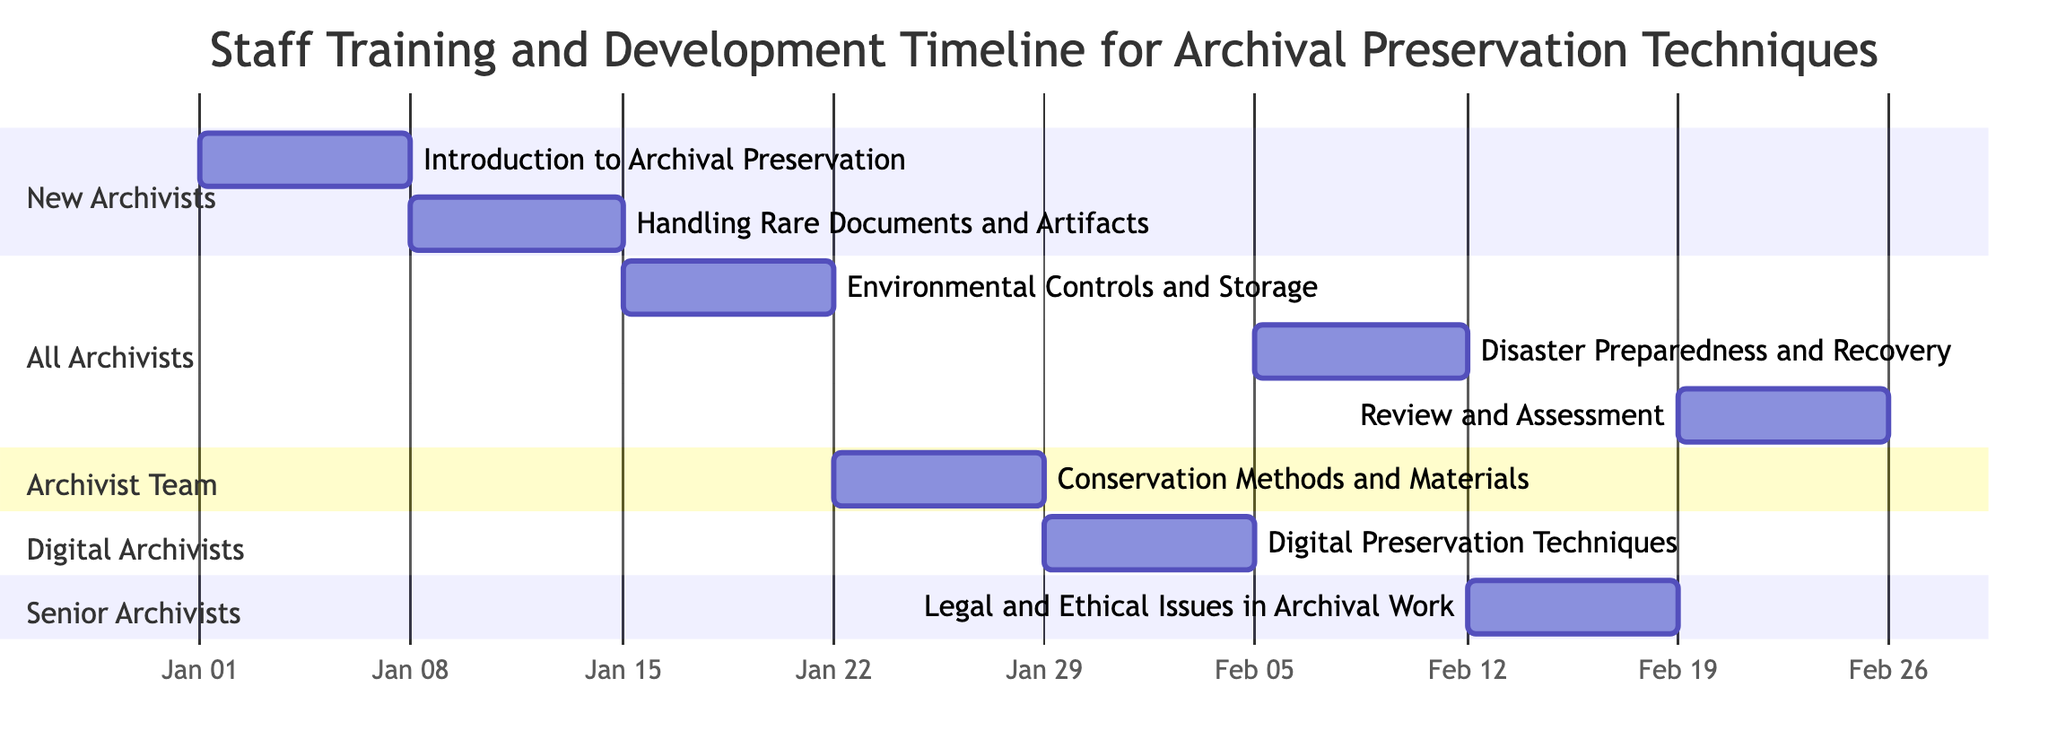What is the duration of the "Introduction to Archival Preservation" task? The task starts on January 1, 2023, and ends on January 7, 2023, which gives it a total duration of 7 days.
Answer: 7 days Who is assigned to the "Digital Preservation Techniques"? The diagram indicates that "Digital Archivists" are responsible for the "Digital Preservation Techniques" task.
Answer: Digital Archivists How many tasks are assigned to the "All Archivists"? There are three tasks listed under the "All Archivists" section: Environmental Controls and Storage, Disaster Preparedness and Recovery, and Review and Assessment.
Answer: 3 What are the dates for the "Conservation Methods and Materials" task? The task begins on January 22, 2023, and concludes on January 28, 2023, according to the section for the Archivist Team.
Answer: January 22 to January 28, 2023 Which task follows "Handling Rare Documents and Artifacts"? The task that follows is "Environmental Controls and Storage," as it starts on January 15, 2023, right after the end of "Handling Rare Documents and Artifacts."
Answer: Environmental Controls and Storage Is there any overlap between the tasks assigned to "All Archivists"? The tasks for "All Archivists" are sequential, with no overlapping dates. The start and end dates do not coincide, thus showing a clear timeline without any overlaps.
Answer: No Which task is the last in the training timeline? The last task according to the timeline is "Review and Assessment," which starts on February 19, 2023, and ends on February 25, 2023.
Answer: Review and Assessment What is the main focus of the "Legal and Ethical Issues in Archival Work" task? The description indicates this task focuses on the understanding of legal and ethical responsibilities in archival preservation.
Answer: Legal and ethical responsibilities 